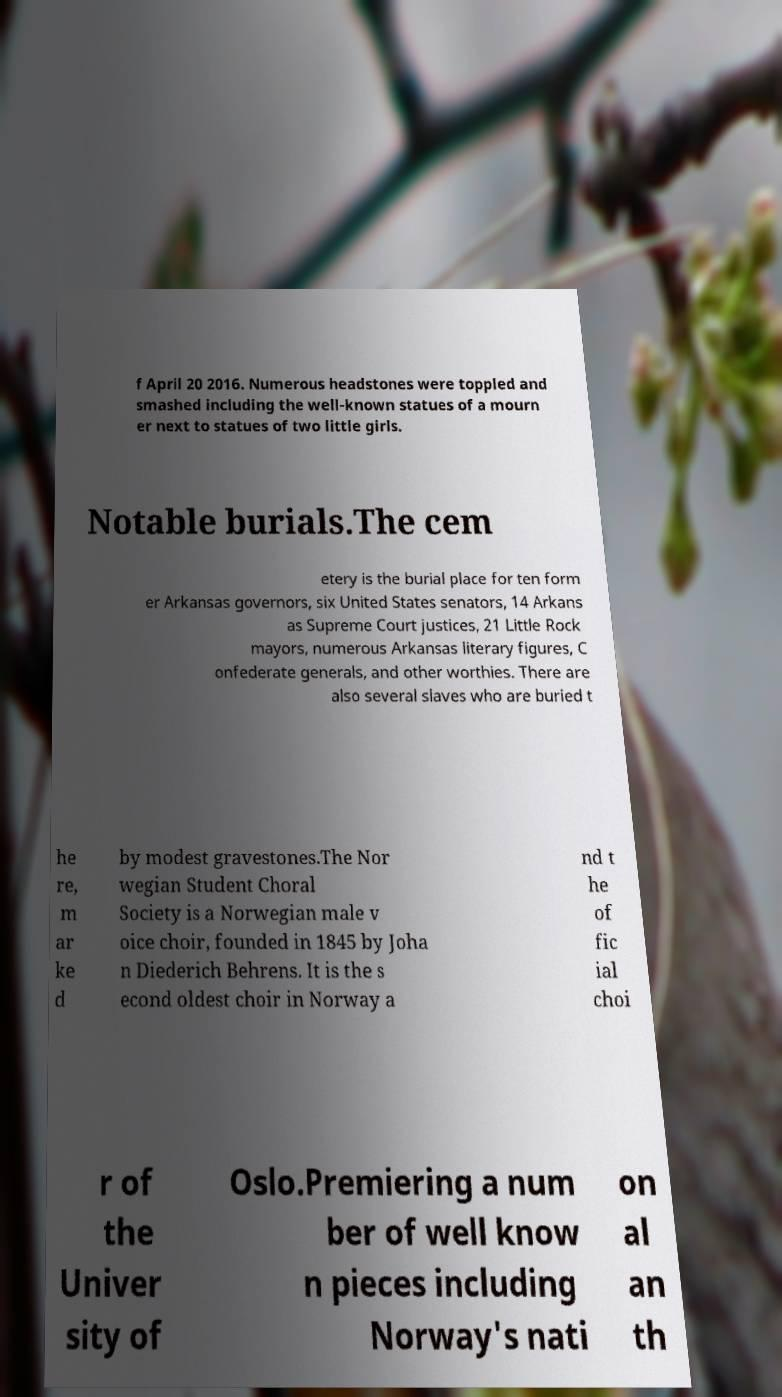For documentation purposes, I need the text within this image transcribed. Could you provide that? f April 20 2016. Numerous headstones were toppled and smashed including the well-known statues of a mourn er next to statues of two little girls. Notable burials.The cem etery is the burial place for ten form er Arkansas governors, six United States senators, 14 Arkans as Supreme Court justices, 21 Little Rock mayors, numerous Arkansas literary figures, C onfederate generals, and other worthies. There are also several slaves who are buried t he re, m ar ke d by modest gravestones.The Nor wegian Student Choral Society is a Norwegian male v oice choir, founded in 1845 by Joha n Diederich Behrens. It is the s econd oldest choir in Norway a nd t he of fic ial choi r of the Univer sity of Oslo.Premiering a num ber of well know n pieces including Norway's nati on al an th 